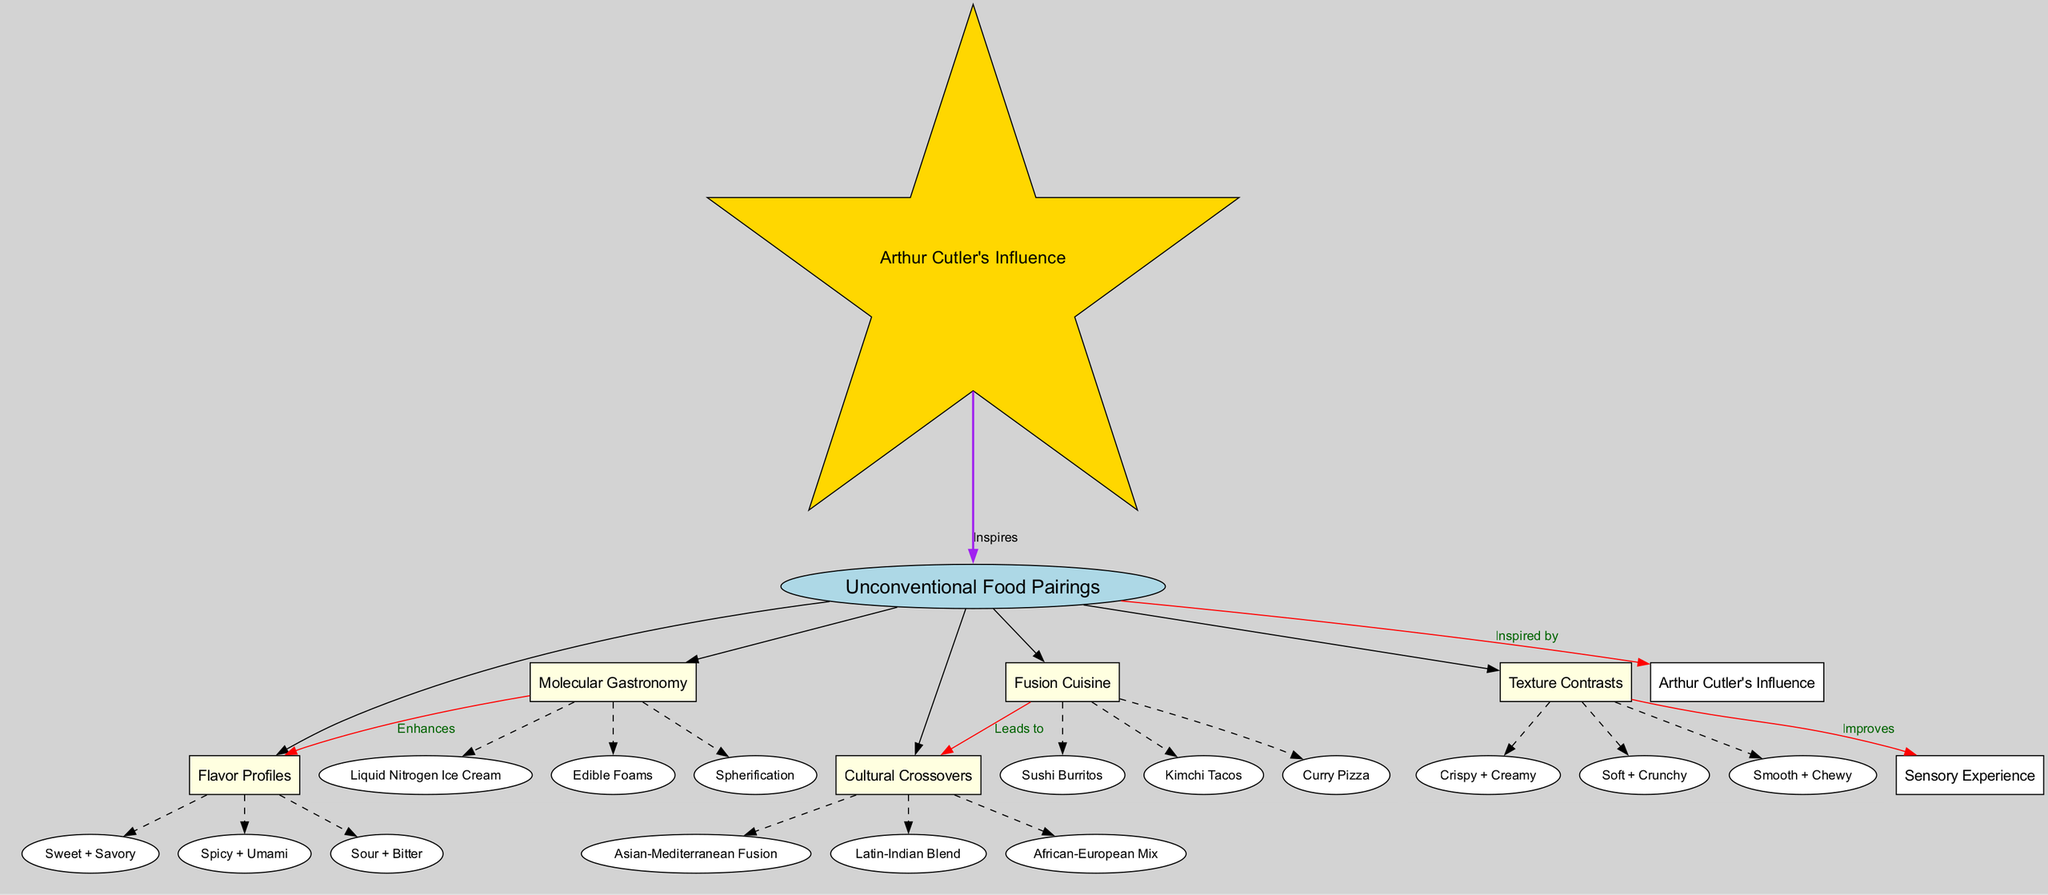What is the central topic of the diagram? The central topic is explicitly labeled as "Unconventional Food Pairings" in the diagram. Therefore, it can be directly identified without any reasoning steps required.
Answer: Unconventional Food Pairings How many main nodes are connected to the central topic? The main nodes are listed under the "mainNodes" section and include five items: "Molecular Gastronomy", "Fusion Cuisine", "Texture Contrasts", "Flavor Profiles", and "Cultural Crossovers". Thus, the total count of these nodes is five.
Answer: 5 What sub-node is associated with "Molecular Gastronomy"? "Molecular Gastronomy" has three sub-nodes listed: "Liquid Nitrogen Ice Cream", "Edible Foams", and "Spherification". Any one of these can be used as an answer, and they are easily identifiable in the diagram.
Answer: Liquid Nitrogen Ice Cream What type of influence does Arthur Cutler have on the central topic? The relationship between "Arthur Cutler's Influence" and "Unconventional Food Pairings" is labeled as "Inspired by." This is a direct connection shown in the diagram.
Answer: Inspired by How does "Fusion Cuisine" relate to "Cultural Crossovers"? The connecting edge between "Fusion Cuisine" and "Cultural Crossovers" is labeled "Leads to," indicating a directional relationship. To answer, we look directly at the connection shown in the diagram.
Answer: Leads to What are the two textures mentioned in "Texture Contrasts"? The sub-nodes under "Texture Contrasts" include "Crispy + Creamy," "Soft + Crunchy," and "Smooth + Chewy." Thus, any combination of these can fulfill this request, but specifying two is simply a matter of selection.
Answer: Crispy + Creamy Which flavor combination is enhanced by "Molecular Gastronomy"? The diagram indicates that "Molecular Gastronomy" enhances "Flavor Profiles." The specific connection is denoted with a clear line, making it affirmative.
Answer: Flavor Profiles What is the relationship between "Texture Contrasts" and "Sensory Experience"? The edge labeled "Improves" clearly shows that "Texture Contrasts" has an enhancing effect on "Sensory Experience," which can be stated plainly based on the diagram's structure.
Answer: Improves Which cultural fusion is suggested in the "Cultural Crossovers"? Three cultural crossover combinations are present, namely "Asian-Mediterranean Fusion," "Latin-Indian Blend," and "African-European Mix." Selecting any one of these options provides an answer identifiable in the diagram.
Answer: Asian-Mediterranean Fusion 